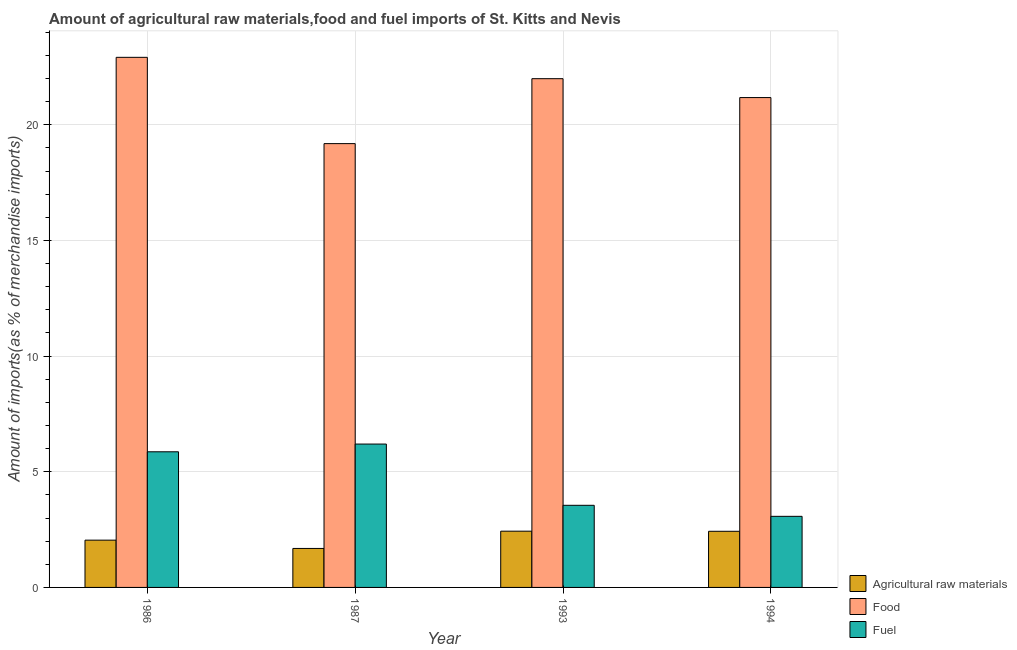How many different coloured bars are there?
Offer a very short reply. 3. Are the number of bars per tick equal to the number of legend labels?
Provide a short and direct response. Yes. How many bars are there on the 2nd tick from the right?
Your answer should be very brief. 3. What is the label of the 4th group of bars from the left?
Offer a very short reply. 1994. What is the percentage of fuel imports in 1987?
Provide a succinct answer. 6.2. Across all years, what is the maximum percentage of fuel imports?
Offer a terse response. 6.2. Across all years, what is the minimum percentage of raw materials imports?
Offer a terse response. 1.68. In which year was the percentage of food imports maximum?
Offer a terse response. 1986. In which year was the percentage of raw materials imports minimum?
Give a very brief answer. 1987. What is the total percentage of fuel imports in the graph?
Give a very brief answer. 18.68. What is the difference between the percentage of fuel imports in 1986 and that in 1987?
Offer a very short reply. -0.33. What is the difference between the percentage of fuel imports in 1993 and the percentage of raw materials imports in 1986?
Provide a succinct answer. -2.31. What is the average percentage of fuel imports per year?
Your answer should be compact. 4.67. In the year 1994, what is the difference between the percentage of raw materials imports and percentage of fuel imports?
Your answer should be compact. 0. What is the ratio of the percentage of food imports in 1986 to that in 1993?
Your answer should be very brief. 1.04. What is the difference between the highest and the second highest percentage of fuel imports?
Give a very brief answer. 0.33. What is the difference between the highest and the lowest percentage of raw materials imports?
Ensure brevity in your answer.  0.75. In how many years, is the percentage of raw materials imports greater than the average percentage of raw materials imports taken over all years?
Provide a succinct answer. 2. Is the sum of the percentage of raw materials imports in 1986 and 1987 greater than the maximum percentage of fuel imports across all years?
Your answer should be compact. Yes. What does the 2nd bar from the left in 1994 represents?
Your response must be concise. Food. What does the 1st bar from the right in 1986 represents?
Your answer should be very brief. Fuel. Is it the case that in every year, the sum of the percentage of raw materials imports and percentage of food imports is greater than the percentage of fuel imports?
Your answer should be compact. Yes. Are all the bars in the graph horizontal?
Your answer should be very brief. No. How many years are there in the graph?
Keep it short and to the point. 4. Does the graph contain grids?
Your response must be concise. Yes. Where does the legend appear in the graph?
Offer a terse response. Bottom right. How many legend labels are there?
Provide a short and direct response. 3. What is the title of the graph?
Your answer should be compact. Amount of agricultural raw materials,food and fuel imports of St. Kitts and Nevis. Does "Argument" appear as one of the legend labels in the graph?
Provide a short and direct response. No. What is the label or title of the Y-axis?
Give a very brief answer. Amount of imports(as % of merchandise imports). What is the Amount of imports(as % of merchandise imports) of Agricultural raw materials in 1986?
Provide a short and direct response. 2.04. What is the Amount of imports(as % of merchandise imports) of Food in 1986?
Make the answer very short. 22.91. What is the Amount of imports(as % of merchandise imports) in Fuel in 1986?
Provide a succinct answer. 5.86. What is the Amount of imports(as % of merchandise imports) in Agricultural raw materials in 1987?
Ensure brevity in your answer.  1.68. What is the Amount of imports(as % of merchandise imports) of Food in 1987?
Make the answer very short. 19.18. What is the Amount of imports(as % of merchandise imports) in Fuel in 1987?
Keep it short and to the point. 6.2. What is the Amount of imports(as % of merchandise imports) in Agricultural raw materials in 1993?
Provide a succinct answer. 2.43. What is the Amount of imports(as % of merchandise imports) of Food in 1993?
Offer a very short reply. 21.99. What is the Amount of imports(as % of merchandise imports) of Fuel in 1993?
Keep it short and to the point. 3.55. What is the Amount of imports(as % of merchandise imports) in Agricultural raw materials in 1994?
Your answer should be compact. 2.43. What is the Amount of imports(as % of merchandise imports) in Food in 1994?
Keep it short and to the point. 21.17. What is the Amount of imports(as % of merchandise imports) of Fuel in 1994?
Give a very brief answer. 3.07. Across all years, what is the maximum Amount of imports(as % of merchandise imports) of Agricultural raw materials?
Your response must be concise. 2.43. Across all years, what is the maximum Amount of imports(as % of merchandise imports) of Food?
Give a very brief answer. 22.91. Across all years, what is the maximum Amount of imports(as % of merchandise imports) of Fuel?
Your response must be concise. 6.2. Across all years, what is the minimum Amount of imports(as % of merchandise imports) in Agricultural raw materials?
Provide a short and direct response. 1.68. Across all years, what is the minimum Amount of imports(as % of merchandise imports) in Food?
Your answer should be compact. 19.18. Across all years, what is the minimum Amount of imports(as % of merchandise imports) of Fuel?
Provide a succinct answer. 3.07. What is the total Amount of imports(as % of merchandise imports) in Agricultural raw materials in the graph?
Offer a terse response. 8.59. What is the total Amount of imports(as % of merchandise imports) in Food in the graph?
Ensure brevity in your answer.  85.27. What is the total Amount of imports(as % of merchandise imports) in Fuel in the graph?
Provide a succinct answer. 18.68. What is the difference between the Amount of imports(as % of merchandise imports) in Agricultural raw materials in 1986 and that in 1987?
Provide a succinct answer. 0.36. What is the difference between the Amount of imports(as % of merchandise imports) in Food in 1986 and that in 1987?
Provide a succinct answer. 3.73. What is the difference between the Amount of imports(as % of merchandise imports) of Fuel in 1986 and that in 1987?
Provide a succinct answer. -0.33. What is the difference between the Amount of imports(as % of merchandise imports) of Agricultural raw materials in 1986 and that in 1993?
Ensure brevity in your answer.  -0.39. What is the difference between the Amount of imports(as % of merchandise imports) in Food in 1986 and that in 1993?
Your answer should be compact. 0.92. What is the difference between the Amount of imports(as % of merchandise imports) of Fuel in 1986 and that in 1993?
Provide a succinct answer. 2.31. What is the difference between the Amount of imports(as % of merchandise imports) of Agricultural raw materials in 1986 and that in 1994?
Your answer should be compact. -0.38. What is the difference between the Amount of imports(as % of merchandise imports) of Food in 1986 and that in 1994?
Keep it short and to the point. 1.74. What is the difference between the Amount of imports(as % of merchandise imports) in Fuel in 1986 and that in 1994?
Keep it short and to the point. 2.79. What is the difference between the Amount of imports(as % of merchandise imports) in Agricultural raw materials in 1987 and that in 1993?
Offer a very short reply. -0.75. What is the difference between the Amount of imports(as % of merchandise imports) in Food in 1987 and that in 1993?
Make the answer very short. -2.81. What is the difference between the Amount of imports(as % of merchandise imports) of Fuel in 1987 and that in 1993?
Ensure brevity in your answer.  2.65. What is the difference between the Amount of imports(as % of merchandise imports) of Agricultural raw materials in 1987 and that in 1994?
Provide a succinct answer. -0.74. What is the difference between the Amount of imports(as % of merchandise imports) of Food in 1987 and that in 1994?
Your answer should be compact. -1.99. What is the difference between the Amount of imports(as % of merchandise imports) in Fuel in 1987 and that in 1994?
Give a very brief answer. 3.12. What is the difference between the Amount of imports(as % of merchandise imports) of Agricultural raw materials in 1993 and that in 1994?
Your response must be concise. 0. What is the difference between the Amount of imports(as % of merchandise imports) of Food in 1993 and that in 1994?
Offer a very short reply. 0.82. What is the difference between the Amount of imports(as % of merchandise imports) in Fuel in 1993 and that in 1994?
Your response must be concise. 0.48. What is the difference between the Amount of imports(as % of merchandise imports) in Agricultural raw materials in 1986 and the Amount of imports(as % of merchandise imports) in Food in 1987?
Give a very brief answer. -17.14. What is the difference between the Amount of imports(as % of merchandise imports) of Agricultural raw materials in 1986 and the Amount of imports(as % of merchandise imports) of Fuel in 1987?
Ensure brevity in your answer.  -4.15. What is the difference between the Amount of imports(as % of merchandise imports) of Food in 1986 and the Amount of imports(as % of merchandise imports) of Fuel in 1987?
Your response must be concise. 16.72. What is the difference between the Amount of imports(as % of merchandise imports) in Agricultural raw materials in 1986 and the Amount of imports(as % of merchandise imports) in Food in 1993?
Your answer should be very brief. -19.95. What is the difference between the Amount of imports(as % of merchandise imports) in Agricultural raw materials in 1986 and the Amount of imports(as % of merchandise imports) in Fuel in 1993?
Make the answer very short. -1.51. What is the difference between the Amount of imports(as % of merchandise imports) in Food in 1986 and the Amount of imports(as % of merchandise imports) in Fuel in 1993?
Offer a terse response. 19.36. What is the difference between the Amount of imports(as % of merchandise imports) of Agricultural raw materials in 1986 and the Amount of imports(as % of merchandise imports) of Food in 1994?
Offer a terse response. -19.13. What is the difference between the Amount of imports(as % of merchandise imports) in Agricultural raw materials in 1986 and the Amount of imports(as % of merchandise imports) in Fuel in 1994?
Your answer should be very brief. -1.03. What is the difference between the Amount of imports(as % of merchandise imports) in Food in 1986 and the Amount of imports(as % of merchandise imports) in Fuel in 1994?
Your answer should be very brief. 19.84. What is the difference between the Amount of imports(as % of merchandise imports) of Agricultural raw materials in 1987 and the Amount of imports(as % of merchandise imports) of Food in 1993?
Offer a terse response. -20.31. What is the difference between the Amount of imports(as % of merchandise imports) of Agricultural raw materials in 1987 and the Amount of imports(as % of merchandise imports) of Fuel in 1993?
Give a very brief answer. -1.86. What is the difference between the Amount of imports(as % of merchandise imports) in Food in 1987 and the Amount of imports(as % of merchandise imports) in Fuel in 1993?
Provide a short and direct response. 15.64. What is the difference between the Amount of imports(as % of merchandise imports) of Agricultural raw materials in 1987 and the Amount of imports(as % of merchandise imports) of Food in 1994?
Your answer should be compact. -19.49. What is the difference between the Amount of imports(as % of merchandise imports) of Agricultural raw materials in 1987 and the Amount of imports(as % of merchandise imports) of Fuel in 1994?
Offer a very short reply. -1.39. What is the difference between the Amount of imports(as % of merchandise imports) of Food in 1987 and the Amount of imports(as % of merchandise imports) of Fuel in 1994?
Your response must be concise. 16.11. What is the difference between the Amount of imports(as % of merchandise imports) of Agricultural raw materials in 1993 and the Amount of imports(as % of merchandise imports) of Food in 1994?
Make the answer very short. -18.74. What is the difference between the Amount of imports(as % of merchandise imports) of Agricultural raw materials in 1993 and the Amount of imports(as % of merchandise imports) of Fuel in 1994?
Provide a short and direct response. -0.64. What is the difference between the Amount of imports(as % of merchandise imports) of Food in 1993 and the Amount of imports(as % of merchandise imports) of Fuel in 1994?
Your answer should be very brief. 18.92. What is the average Amount of imports(as % of merchandise imports) in Agricultural raw materials per year?
Provide a succinct answer. 2.15. What is the average Amount of imports(as % of merchandise imports) in Food per year?
Make the answer very short. 21.32. What is the average Amount of imports(as % of merchandise imports) in Fuel per year?
Your answer should be very brief. 4.67. In the year 1986, what is the difference between the Amount of imports(as % of merchandise imports) of Agricultural raw materials and Amount of imports(as % of merchandise imports) of Food?
Ensure brevity in your answer.  -20.87. In the year 1986, what is the difference between the Amount of imports(as % of merchandise imports) of Agricultural raw materials and Amount of imports(as % of merchandise imports) of Fuel?
Provide a short and direct response. -3.82. In the year 1986, what is the difference between the Amount of imports(as % of merchandise imports) in Food and Amount of imports(as % of merchandise imports) in Fuel?
Offer a very short reply. 17.05. In the year 1987, what is the difference between the Amount of imports(as % of merchandise imports) of Agricultural raw materials and Amount of imports(as % of merchandise imports) of Food?
Your answer should be very brief. -17.5. In the year 1987, what is the difference between the Amount of imports(as % of merchandise imports) of Agricultural raw materials and Amount of imports(as % of merchandise imports) of Fuel?
Make the answer very short. -4.51. In the year 1987, what is the difference between the Amount of imports(as % of merchandise imports) of Food and Amount of imports(as % of merchandise imports) of Fuel?
Your answer should be compact. 12.99. In the year 1993, what is the difference between the Amount of imports(as % of merchandise imports) of Agricultural raw materials and Amount of imports(as % of merchandise imports) of Food?
Your response must be concise. -19.56. In the year 1993, what is the difference between the Amount of imports(as % of merchandise imports) of Agricultural raw materials and Amount of imports(as % of merchandise imports) of Fuel?
Give a very brief answer. -1.12. In the year 1993, what is the difference between the Amount of imports(as % of merchandise imports) of Food and Amount of imports(as % of merchandise imports) of Fuel?
Provide a short and direct response. 18.44. In the year 1994, what is the difference between the Amount of imports(as % of merchandise imports) of Agricultural raw materials and Amount of imports(as % of merchandise imports) of Food?
Your answer should be very brief. -18.75. In the year 1994, what is the difference between the Amount of imports(as % of merchandise imports) of Agricultural raw materials and Amount of imports(as % of merchandise imports) of Fuel?
Your answer should be very brief. -0.65. In the year 1994, what is the difference between the Amount of imports(as % of merchandise imports) in Food and Amount of imports(as % of merchandise imports) in Fuel?
Your answer should be compact. 18.1. What is the ratio of the Amount of imports(as % of merchandise imports) in Agricultural raw materials in 1986 to that in 1987?
Your response must be concise. 1.21. What is the ratio of the Amount of imports(as % of merchandise imports) in Food in 1986 to that in 1987?
Make the answer very short. 1.19. What is the ratio of the Amount of imports(as % of merchandise imports) in Fuel in 1986 to that in 1987?
Your answer should be very brief. 0.95. What is the ratio of the Amount of imports(as % of merchandise imports) of Agricultural raw materials in 1986 to that in 1993?
Make the answer very short. 0.84. What is the ratio of the Amount of imports(as % of merchandise imports) of Food in 1986 to that in 1993?
Offer a terse response. 1.04. What is the ratio of the Amount of imports(as % of merchandise imports) of Fuel in 1986 to that in 1993?
Give a very brief answer. 1.65. What is the ratio of the Amount of imports(as % of merchandise imports) of Agricultural raw materials in 1986 to that in 1994?
Your answer should be compact. 0.84. What is the ratio of the Amount of imports(as % of merchandise imports) of Food in 1986 to that in 1994?
Make the answer very short. 1.08. What is the ratio of the Amount of imports(as % of merchandise imports) in Fuel in 1986 to that in 1994?
Your answer should be compact. 1.91. What is the ratio of the Amount of imports(as % of merchandise imports) in Agricultural raw materials in 1987 to that in 1993?
Ensure brevity in your answer.  0.69. What is the ratio of the Amount of imports(as % of merchandise imports) in Food in 1987 to that in 1993?
Offer a terse response. 0.87. What is the ratio of the Amount of imports(as % of merchandise imports) in Fuel in 1987 to that in 1993?
Your response must be concise. 1.75. What is the ratio of the Amount of imports(as % of merchandise imports) in Agricultural raw materials in 1987 to that in 1994?
Your answer should be very brief. 0.69. What is the ratio of the Amount of imports(as % of merchandise imports) of Food in 1987 to that in 1994?
Provide a succinct answer. 0.91. What is the ratio of the Amount of imports(as % of merchandise imports) in Fuel in 1987 to that in 1994?
Your response must be concise. 2.02. What is the ratio of the Amount of imports(as % of merchandise imports) of Agricultural raw materials in 1993 to that in 1994?
Keep it short and to the point. 1. What is the ratio of the Amount of imports(as % of merchandise imports) of Food in 1993 to that in 1994?
Ensure brevity in your answer.  1.04. What is the ratio of the Amount of imports(as % of merchandise imports) of Fuel in 1993 to that in 1994?
Make the answer very short. 1.16. What is the difference between the highest and the second highest Amount of imports(as % of merchandise imports) of Agricultural raw materials?
Your response must be concise. 0. What is the difference between the highest and the second highest Amount of imports(as % of merchandise imports) of Food?
Keep it short and to the point. 0.92. What is the difference between the highest and the second highest Amount of imports(as % of merchandise imports) in Fuel?
Provide a short and direct response. 0.33. What is the difference between the highest and the lowest Amount of imports(as % of merchandise imports) in Agricultural raw materials?
Your answer should be compact. 0.75. What is the difference between the highest and the lowest Amount of imports(as % of merchandise imports) in Food?
Make the answer very short. 3.73. What is the difference between the highest and the lowest Amount of imports(as % of merchandise imports) of Fuel?
Offer a terse response. 3.12. 